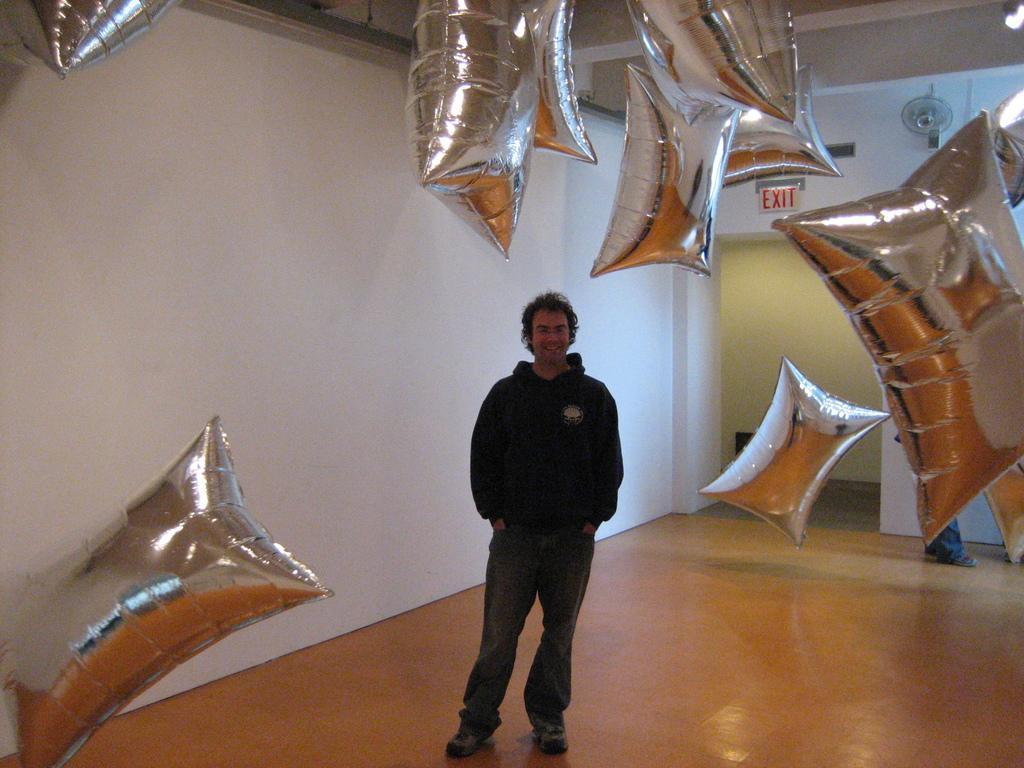Can you describe this image briefly? In this picture there is a man with black jacket is standing and smiling. At the back there are pillows in the air. On the right side of the image there are pillows and there is a person standing and there is a board and fan on the wall and there is text on the board. At the top there is a light. At the bottom there is a floor. On the left side of the image there are pillows in the air. 